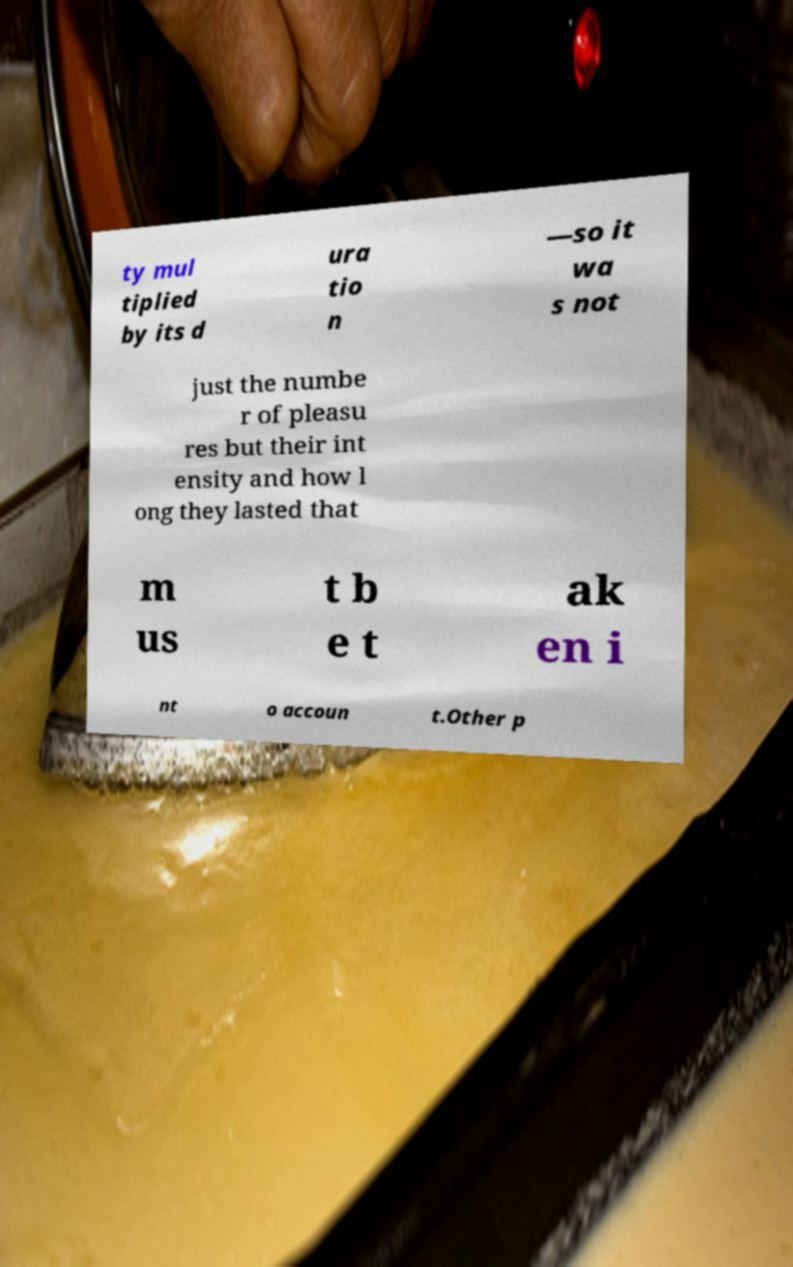There's text embedded in this image that I need extracted. Can you transcribe it verbatim? ty mul tiplied by its d ura tio n —so it wa s not just the numbe r of pleasu res but their int ensity and how l ong they lasted that m us t b e t ak en i nt o accoun t.Other p 